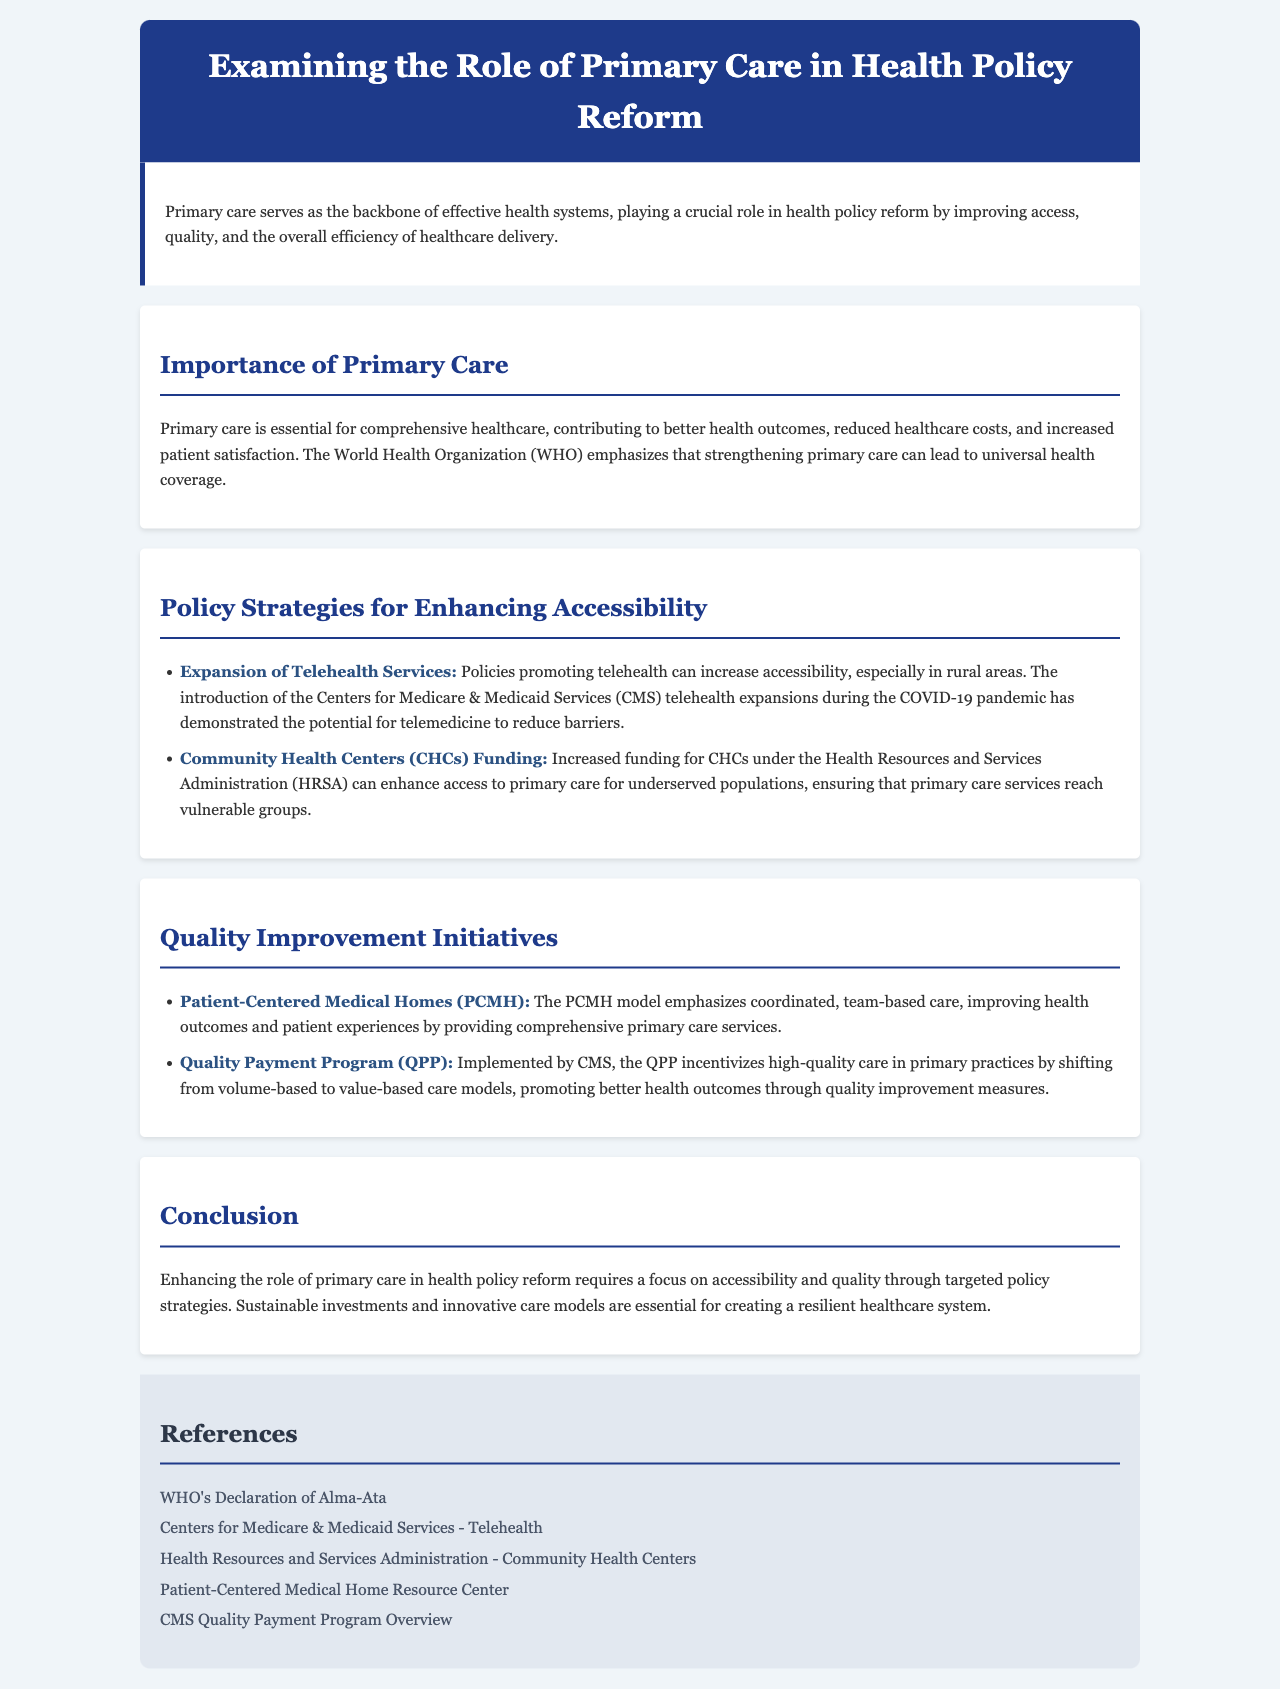What is the main role of primary care in health systems? The introduction states that primary care serves as the backbone of effective health systems, playing a crucial role in health policy reform by improving access, quality, and the overall efficiency of healthcare delivery.
Answer: Backbone of effective health systems What does the WHO emphasize regarding primary care? The document highlights that the World Health Organization (WHO) emphasizes that strengthening primary care can lead to universal health coverage.
Answer: Universal health coverage What is one strategy for enhancing accessibility mentioned in the document? The section on policy strategies lists "Expansion of Telehealth Services" which can increase accessibility, especially in rural areas.
Answer: Expansion of Telehealth Services What model is used to improve health outcomes and patient experiences? The document discusses the "Patient-Centered Medical Homes (PCMH)" model as a way to improve health outcomes and patient experiences.
Answer: Patient-Centered Medical Homes (PCMH) What does the Quality Payment Program (QPP) incentivize in primary practices? The QPP incentivizes high-quality care in primary practices by promoting better health outcomes through quality improvement measures.
Answer: High-quality care 